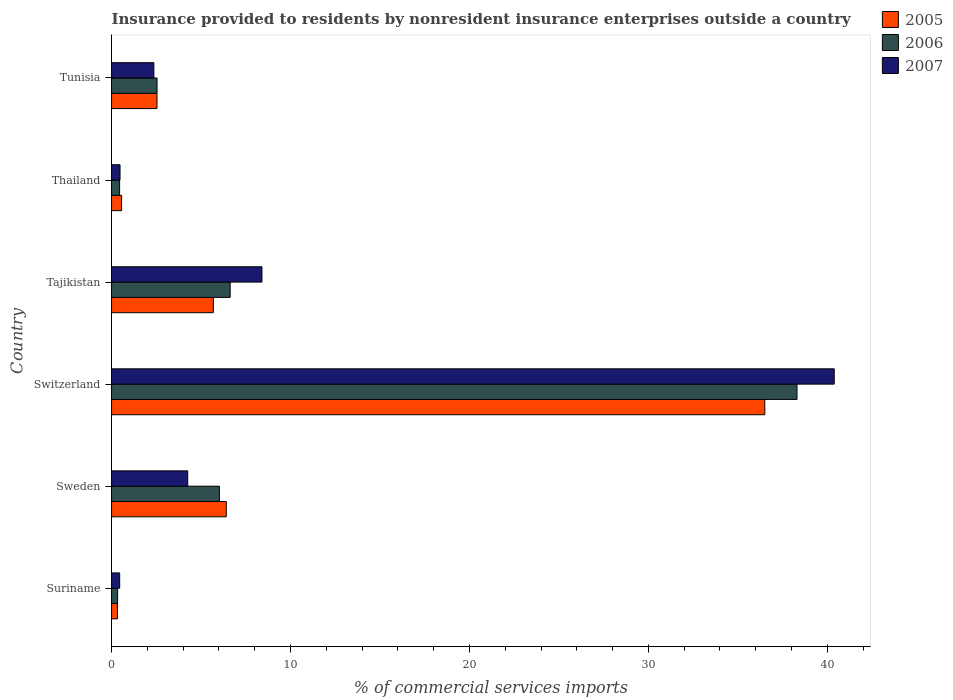How many different coloured bars are there?
Give a very brief answer. 3. How many groups of bars are there?
Keep it short and to the point. 6. Are the number of bars per tick equal to the number of legend labels?
Your answer should be compact. Yes. Are the number of bars on each tick of the Y-axis equal?
Provide a short and direct response. Yes. How many bars are there on the 1st tick from the top?
Ensure brevity in your answer.  3. How many bars are there on the 5th tick from the bottom?
Ensure brevity in your answer.  3. What is the label of the 1st group of bars from the top?
Your answer should be compact. Tunisia. In how many cases, is the number of bars for a given country not equal to the number of legend labels?
Your answer should be compact. 0. What is the Insurance provided to residents in 2005 in Tajikistan?
Keep it short and to the point. 5.69. Across all countries, what is the maximum Insurance provided to residents in 2006?
Offer a terse response. 38.3. Across all countries, what is the minimum Insurance provided to residents in 2005?
Keep it short and to the point. 0.33. In which country was the Insurance provided to residents in 2005 maximum?
Give a very brief answer. Switzerland. In which country was the Insurance provided to residents in 2006 minimum?
Give a very brief answer. Suriname. What is the total Insurance provided to residents in 2005 in the graph?
Ensure brevity in your answer.  52.03. What is the difference between the Insurance provided to residents in 2007 in Tajikistan and that in Tunisia?
Ensure brevity in your answer.  6.04. What is the difference between the Insurance provided to residents in 2005 in Tunisia and the Insurance provided to residents in 2007 in Switzerland?
Keep it short and to the point. -37.85. What is the average Insurance provided to residents in 2007 per country?
Ensure brevity in your answer.  9.39. What is the difference between the Insurance provided to residents in 2007 and Insurance provided to residents in 2005 in Tunisia?
Make the answer very short. -0.17. In how many countries, is the Insurance provided to residents in 2005 greater than 6 %?
Your answer should be compact. 2. What is the ratio of the Insurance provided to residents in 2006 in Sweden to that in Tunisia?
Keep it short and to the point. 2.37. Is the Insurance provided to residents in 2006 in Suriname less than that in Switzerland?
Your response must be concise. Yes. What is the difference between the highest and the second highest Insurance provided to residents in 2006?
Your answer should be very brief. 31.68. What is the difference between the highest and the lowest Insurance provided to residents in 2006?
Give a very brief answer. 37.97. In how many countries, is the Insurance provided to residents in 2007 greater than the average Insurance provided to residents in 2007 taken over all countries?
Your answer should be compact. 1. Is the sum of the Insurance provided to residents in 2007 in Suriname and Tunisia greater than the maximum Insurance provided to residents in 2006 across all countries?
Your response must be concise. No. Is it the case that in every country, the sum of the Insurance provided to residents in 2005 and Insurance provided to residents in 2007 is greater than the Insurance provided to residents in 2006?
Your answer should be compact. Yes. How many bars are there?
Your answer should be compact. 18. How many countries are there in the graph?
Offer a very short reply. 6. What is the difference between two consecutive major ticks on the X-axis?
Offer a very short reply. 10. Are the values on the major ticks of X-axis written in scientific E-notation?
Your answer should be very brief. No. What is the title of the graph?
Ensure brevity in your answer.  Insurance provided to residents by nonresident insurance enterprises outside a country. What is the label or title of the X-axis?
Your answer should be very brief. % of commercial services imports. What is the label or title of the Y-axis?
Give a very brief answer. Country. What is the % of commercial services imports of 2005 in Suriname?
Your answer should be compact. 0.33. What is the % of commercial services imports of 2006 in Suriname?
Provide a short and direct response. 0.34. What is the % of commercial services imports in 2007 in Suriname?
Provide a short and direct response. 0.45. What is the % of commercial services imports of 2005 in Sweden?
Your response must be concise. 6.41. What is the % of commercial services imports in 2006 in Sweden?
Your answer should be very brief. 6.03. What is the % of commercial services imports in 2007 in Sweden?
Offer a very short reply. 4.26. What is the % of commercial services imports in 2005 in Switzerland?
Your answer should be compact. 36.5. What is the % of commercial services imports of 2006 in Switzerland?
Make the answer very short. 38.3. What is the % of commercial services imports in 2007 in Switzerland?
Your response must be concise. 40.39. What is the % of commercial services imports of 2005 in Tajikistan?
Offer a terse response. 5.69. What is the % of commercial services imports in 2006 in Tajikistan?
Provide a succinct answer. 6.63. What is the % of commercial services imports of 2007 in Tajikistan?
Your answer should be very brief. 8.4. What is the % of commercial services imports in 2005 in Thailand?
Give a very brief answer. 0.56. What is the % of commercial services imports of 2006 in Thailand?
Keep it short and to the point. 0.45. What is the % of commercial services imports of 2007 in Thailand?
Ensure brevity in your answer.  0.47. What is the % of commercial services imports of 2005 in Tunisia?
Your answer should be compact. 2.54. What is the % of commercial services imports of 2006 in Tunisia?
Make the answer very short. 2.54. What is the % of commercial services imports in 2007 in Tunisia?
Give a very brief answer. 2.36. Across all countries, what is the maximum % of commercial services imports of 2005?
Your answer should be very brief. 36.5. Across all countries, what is the maximum % of commercial services imports in 2006?
Your answer should be compact. 38.3. Across all countries, what is the maximum % of commercial services imports in 2007?
Keep it short and to the point. 40.39. Across all countries, what is the minimum % of commercial services imports of 2005?
Your answer should be very brief. 0.33. Across all countries, what is the minimum % of commercial services imports of 2006?
Make the answer very short. 0.34. Across all countries, what is the minimum % of commercial services imports in 2007?
Offer a terse response. 0.45. What is the total % of commercial services imports of 2005 in the graph?
Offer a very short reply. 52.03. What is the total % of commercial services imports of 2006 in the graph?
Make the answer very short. 54.29. What is the total % of commercial services imports of 2007 in the graph?
Offer a terse response. 56.34. What is the difference between the % of commercial services imports in 2005 in Suriname and that in Sweden?
Give a very brief answer. -6.08. What is the difference between the % of commercial services imports of 2006 in Suriname and that in Sweden?
Ensure brevity in your answer.  -5.69. What is the difference between the % of commercial services imports in 2007 in Suriname and that in Sweden?
Provide a short and direct response. -3.8. What is the difference between the % of commercial services imports of 2005 in Suriname and that in Switzerland?
Your response must be concise. -36.18. What is the difference between the % of commercial services imports of 2006 in Suriname and that in Switzerland?
Your answer should be compact. -37.97. What is the difference between the % of commercial services imports in 2007 in Suriname and that in Switzerland?
Ensure brevity in your answer.  -39.93. What is the difference between the % of commercial services imports in 2005 in Suriname and that in Tajikistan?
Your answer should be compact. -5.36. What is the difference between the % of commercial services imports in 2006 in Suriname and that in Tajikistan?
Provide a short and direct response. -6.29. What is the difference between the % of commercial services imports in 2007 in Suriname and that in Tajikistan?
Keep it short and to the point. -7.95. What is the difference between the % of commercial services imports of 2005 in Suriname and that in Thailand?
Your answer should be very brief. -0.23. What is the difference between the % of commercial services imports in 2006 in Suriname and that in Thailand?
Offer a terse response. -0.11. What is the difference between the % of commercial services imports in 2007 in Suriname and that in Thailand?
Give a very brief answer. -0.02. What is the difference between the % of commercial services imports in 2005 in Suriname and that in Tunisia?
Provide a succinct answer. -2.21. What is the difference between the % of commercial services imports of 2006 in Suriname and that in Tunisia?
Offer a terse response. -2.2. What is the difference between the % of commercial services imports of 2007 in Suriname and that in Tunisia?
Provide a succinct answer. -1.91. What is the difference between the % of commercial services imports of 2005 in Sweden and that in Switzerland?
Your response must be concise. -30.09. What is the difference between the % of commercial services imports of 2006 in Sweden and that in Switzerland?
Ensure brevity in your answer.  -32.28. What is the difference between the % of commercial services imports of 2007 in Sweden and that in Switzerland?
Offer a terse response. -36.13. What is the difference between the % of commercial services imports in 2005 in Sweden and that in Tajikistan?
Ensure brevity in your answer.  0.73. What is the difference between the % of commercial services imports of 2006 in Sweden and that in Tajikistan?
Your answer should be compact. -0.6. What is the difference between the % of commercial services imports of 2007 in Sweden and that in Tajikistan?
Keep it short and to the point. -4.15. What is the difference between the % of commercial services imports of 2005 in Sweden and that in Thailand?
Provide a short and direct response. 5.85. What is the difference between the % of commercial services imports in 2006 in Sweden and that in Thailand?
Ensure brevity in your answer.  5.58. What is the difference between the % of commercial services imports in 2007 in Sweden and that in Thailand?
Your answer should be very brief. 3.78. What is the difference between the % of commercial services imports in 2005 in Sweden and that in Tunisia?
Your answer should be compact. 3.87. What is the difference between the % of commercial services imports of 2006 in Sweden and that in Tunisia?
Your answer should be compact. 3.49. What is the difference between the % of commercial services imports of 2007 in Sweden and that in Tunisia?
Your response must be concise. 1.89. What is the difference between the % of commercial services imports of 2005 in Switzerland and that in Tajikistan?
Give a very brief answer. 30.82. What is the difference between the % of commercial services imports in 2006 in Switzerland and that in Tajikistan?
Offer a terse response. 31.68. What is the difference between the % of commercial services imports of 2007 in Switzerland and that in Tajikistan?
Give a very brief answer. 31.98. What is the difference between the % of commercial services imports of 2005 in Switzerland and that in Thailand?
Give a very brief answer. 35.94. What is the difference between the % of commercial services imports of 2006 in Switzerland and that in Thailand?
Offer a terse response. 37.85. What is the difference between the % of commercial services imports in 2007 in Switzerland and that in Thailand?
Make the answer very short. 39.91. What is the difference between the % of commercial services imports of 2005 in Switzerland and that in Tunisia?
Give a very brief answer. 33.96. What is the difference between the % of commercial services imports in 2006 in Switzerland and that in Tunisia?
Provide a short and direct response. 35.76. What is the difference between the % of commercial services imports in 2007 in Switzerland and that in Tunisia?
Keep it short and to the point. 38.02. What is the difference between the % of commercial services imports of 2005 in Tajikistan and that in Thailand?
Keep it short and to the point. 5.13. What is the difference between the % of commercial services imports of 2006 in Tajikistan and that in Thailand?
Provide a succinct answer. 6.18. What is the difference between the % of commercial services imports in 2007 in Tajikistan and that in Thailand?
Offer a very short reply. 7.93. What is the difference between the % of commercial services imports of 2005 in Tajikistan and that in Tunisia?
Give a very brief answer. 3.15. What is the difference between the % of commercial services imports in 2006 in Tajikistan and that in Tunisia?
Make the answer very short. 4.09. What is the difference between the % of commercial services imports in 2007 in Tajikistan and that in Tunisia?
Provide a succinct answer. 6.04. What is the difference between the % of commercial services imports in 2005 in Thailand and that in Tunisia?
Offer a terse response. -1.98. What is the difference between the % of commercial services imports of 2006 in Thailand and that in Tunisia?
Your answer should be compact. -2.09. What is the difference between the % of commercial services imports in 2007 in Thailand and that in Tunisia?
Offer a very short reply. -1.89. What is the difference between the % of commercial services imports in 2005 in Suriname and the % of commercial services imports in 2006 in Sweden?
Offer a very short reply. -5.7. What is the difference between the % of commercial services imports of 2005 in Suriname and the % of commercial services imports of 2007 in Sweden?
Offer a very short reply. -3.93. What is the difference between the % of commercial services imports of 2006 in Suriname and the % of commercial services imports of 2007 in Sweden?
Make the answer very short. -3.92. What is the difference between the % of commercial services imports of 2005 in Suriname and the % of commercial services imports of 2006 in Switzerland?
Provide a short and direct response. -37.98. What is the difference between the % of commercial services imports in 2005 in Suriname and the % of commercial services imports in 2007 in Switzerland?
Offer a very short reply. -40.06. What is the difference between the % of commercial services imports in 2006 in Suriname and the % of commercial services imports in 2007 in Switzerland?
Make the answer very short. -40.05. What is the difference between the % of commercial services imports of 2005 in Suriname and the % of commercial services imports of 2006 in Tajikistan?
Give a very brief answer. -6.3. What is the difference between the % of commercial services imports in 2005 in Suriname and the % of commercial services imports in 2007 in Tajikistan?
Offer a terse response. -8.08. What is the difference between the % of commercial services imports in 2006 in Suriname and the % of commercial services imports in 2007 in Tajikistan?
Offer a terse response. -8.07. What is the difference between the % of commercial services imports of 2005 in Suriname and the % of commercial services imports of 2006 in Thailand?
Offer a very short reply. -0.12. What is the difference between the % of commercial services imports in 2005 in Suriname and the % of commercial services imports in 2007 in Thailand?
Your answer should be very brief. -0.14. What is the difference between the % of commercial services imports of 2006 in Suriname and the % of commercial services imports of 2007 in Thailand?
Provide a succinct answer. -0.14. What is the difference between the % of commercial services imports in 2005 in Suriname and the % of commercial services imports in 2006 in Tunisia?
Your answer should be very brief. -2.21. What is the difference between the % of commercial services imports in 2005 in Suriname and the % of commercial services imports in 2007 in Tunisia?
Your answer should be compact. -2.04. What is the difference between the % of commercial services imports in 2006 in Suriname and the % of commercial services imports in 2007 in Tunisia?
Give a very brief answer. -2.03. What is the difference between the % of commercial services imports in 2005 in Sweden and the % of commercial services imports in 2006 in Switzerland?
Ensure brevity in your answer.  -31.89. What is the difference between the % of commercial services imports in 2005 in Sweden and the % of commercial services imports in 2007 in Switzerland?
Provide a short and direct response. -33.97. What is the difference between the % of commercial services imports in 2006 in Sweden and the % of commercial services imports in 2007 in Switzerland?
Offer a terse response. -34.36. What is the difference between the % of commercial services imports in 2005 in Sweden and the % of commercial services imports in 2006 in Tajikistan?
Your response must be concise. -0.22. What is the difference between the % of commercial services imports of 2005 in Sweden and the % of commercial services imports of 2007 in Tajikistan?
Ensure brevity in your answer.  -1.99. What is the difference between the % of commercial services imports in 2006 in Sweden and the % of commercial services imports in 2007 in Tajikistan?
Provide a succinct answer. -2.38. What is the difference between the % of commercial services imports of 2005 in Sweden and the % of commercial services imports of 2006 in Thailand?
Make the answer very short. 5.96. What is the difference between the % of commercial services imports of 2005 in Sweden and the % of commercial services imports of 2007 in Thailand?
Make the answer very short. 5.94. What is the difference between the % of commercial services imports of 2006 in Sweden and the % of commercial services imports of 2007 in Thailand?
Ensure brevity in your answer.  5.55. What is the difference between the % of commercial services imports in 2005 in Sweden and the % of commercial services imports in 2006 in Tunisia?
Offer a terse response. 3.87. What is the difference between the % of commercial services imports of 2005 in Sweden and the % of commercial services imports of 2007 in Tunisia?
Provide a succinct answer. 4.05. What is the difference between the % of commercial services imports in 2006 in Sweden and the % of commercial services imports in 2007 in Tunisia?
Make the answer very short. 3.66. What is the difference between the % of commercial services imports in 2005 in Switzerland and the % of commercial services imports in 2006 in Tajikistan?
Offer a very short reply. 29.88. What is the difference between the % of commercial services imports of 2005 in Switzerland and the % of commercial services imports of 2007 in Tajikistan?
Give a very brief answer. 28.1. What is the difference between the % of commercial services imports of 2006 in Switzerland and the % of commercial services imports of 2007 in Tajikistan?
Provide a short and direct response. 29.9. What is the difference between the % of commercial services imports in 2005 in Switzerland and the % of commercial services imports in 2006 in Thailand?
Your answer should be compact. 36.05. What is the difference between the % of commercial services imports in 2005 in Switzerland and the % of commercial services imports in 2007 in Thailand?
Ensure brevity in your answer.  36.03. What is the difference between the % of commercial services imports of 2006 in Switzerland and the % of commercial services imports of 2007 in Thailand?
Your answer should be compact. 37.83. What is the difference between the % of commercial services imports of 2005 in Switzerland and the % of commercial services imports of 2006 in Tunisia?
Provide a succinct answer. 33.96. What is the difference between the % of commercial services imports in 2005 in Switzerland and the % of commercial services imports in 2007 in Tunisia?
Provide a succinct answer. 34.14. What is the difference between the % of commercial services imports in 2006 in Switzerland and the % of commercial services imports in 2007 in Tunisia?
Your response must be concise. 35.94. What is the difference between the % of commercial services imports in 2005 in Tajikistan and the % of commercial services imports in 2006 in Thailand?
Your response must be concise. 5.24. What is the difference between the % of commercial services imports in 2005 in Tajikistan and the % of commercial services imports in 2007 in Thailand?
Your answer should be very brief. 5.21. What is the difference between the % of commercial services imports of 2006 in Tajikistan and the % of commercial services imports of 2007 in Thailand?
Provide a succinct answer. 6.16. What is the difference between the % of commercial services imports of 2005 in Tajikistan and the % of commercial services imports of 2006 in Tunisia?
Your answer should be compact. 3.14. What is the difference between the % of commercial services imports in 2005 in Tajikistan and the % of commercial services imports in 2007 in Tunisia?
Provide a short and direct response. 3.32. What is the difference between the % of commercial services imports in 2006 in Tajikistan and the % of commercial services imports in 2007 in Tunisia?
Your answer should be very brief. 4.26. What is the difference between the % of commercial services imports of 2005 in Thailand and the % of commercial services imports of 2006 in Tunisia?
Give a very brief answer. -1.98. What is the difference between the % of commercial services imports in 2005 in Thailand and the % of commercial services imports in 2007 in Tunisia?
Provide a succinct answer. -1.8. What is the difference between the % of commercial services imports in 2006 in Thailand and the % of commercial services imports in 2007 in Tunisia?
Make the answer very short. -1.92. What is the average % of commercial services imports in 2005 per country?
Make the answer very short. 8.67. What is the average % of commercial services imports in 2006 per country?
Provide a succinct answer. 9.05. What is the average % of commercial services imports in 2007 per country?
Your answer should be very brief. 9.39. What is the difference between the % of commercial services imports in 2005 and % of commercial services imports in 2006 in Suriname?
Provide a succinct answer. -0.01. What is the difference between the % of commercial services imports of 2005 and % of commercial services imports of 2007 in Suriname?
Ensure brevity in your answer.  -0.13. What is the difference between the % of commercial services imports of 2006 and % of commercial services imports of 2007 in Suriname?
Provide a succinct answer. -0.12. What is the difference between the % of commercial services imports of 2005 and % of commercial services imports of 2006 in Sweden?
Provide a short and direct response. 0.38. What is the difference between the % of commercial services imports in 2005 and % of commercial services imports in 2007 in Sweden?
Offer a terse response. 2.16. What is the difference between the % of commercial services imports in 2006 and % of commercial services imports in 2007 in Sweden?
Make the answer very short. 1.77. What is the difference between the % of commercial services imports in 2005 and % of commercial services imports in 2006 in Switzerland?
Your answer should be compact. -1.8. What is the difference between the % of commercial services imports in 2005 and % of commercial services imports in 2007 in Switzerland?
Your answer should be compact. -3.88. What is the difference between the % of commercial services imports in 2006 and % of commercial services imports in 2007 in Switzerland?
Ensure brevity in your answer.  -2.08. What is the difference between the % of commercial services imports of 2005 and % of commercial services imports of 2006 in Tajikistan?
Give a very brief answer. -0.94. What is the difference between the % of commercial services imports in 2005 and % of commercial services imports in 2007 in Tajikistan?
Make the answer very short. -2.72. What is the difference between the % of commercial services imports of 2006 and % of commercial services imports of 2007 in Tajikistan?
Offer a terse response. -1.78. What is the difference between the % of commercial services imports of 2005 and % of commercial services imports of 2006 in Thailand?
Your response must be concise. 0.11. What is the difference between the % of commercial services imports of 2005 and % of commercial services imports of 2007 in Thailand?
Keep it short and to the point. 0.09. What is the difference between the % of commercial services imports in 2006 and % of commercial services imports in 2007 in Thailand?
Give a very brief answer. -0.02. What is the difference between the % of commercial services imports of 2005 and % of commercial services imports of 2006 in Tunisia?
Provide a succinct answer. -0. What is the difference between the % of commercial services imports in 2005 and % of commercial services imports in 2007 in Tunisia?
Keep it short and to the point. 0.17. What is the difference between the % of commercial services imports of 2006 and % of commercial services imports of 2007 in Tunisia?
Offer a very short reply. 0.18. What is the ratio of the % of commercial services imports of 2005 in Suriname to that in Sweden?
Offer a terse response. 0.05. What is the ratio of the % of commercial services imports in 2006 in Suriname to that in Sweden?
Offer a terse response. 0.06. What is the ratio of the % of commercial services imports of 2007 in Suriname to that in Sweden?
Offer a terse response. 0.11. What is the ratio of the % of commercial services imports of 2005 in Suriname to that in Switzerland?
Ensure brevity in your answer.  0.01. What is the ratio of the % of commercial services imports of 2006 in Suriname to that in Switzerland?
Keep it short and to the point. 0.01. What is the ratio of the % of commercial services imports in 2007 in Suriname to that in Switzerland?
Your response must be concise. 0.01. What is the ratio of the % of commercial services imports of 2005 in Suriname to that in Tajikistan?
Offer a very short reply. 0.06. What is the ratio of the % of commercial services imports of 2006 in Suriname to that in Tajikistan?
Offer a terse response. 0.05. What is the ratio of the % of commercial services imports of 2007 in Suriname to that in Tajikistan?
Give a very brief answer. 0.05. What is the ratio of the % of commercial services imports of 2005 in Suriname to that in Thailand?
Your response must be concise. 0.59. What is the ratio of the % of commercial services imports of 2006 in Suriname to that in Thailand?
Your answer should be very brief. 0.75. What is the ratio of the % of commercial services imports of 2007 in Suriname to that in Thailand?
Your response must be concise. 0.96. What is the ratio of the % of commercial services imports of 2005 in Suriname to that in Tunisia?
Offer a terse response. 0.13. What is the ratio of the % of commercial services imports of 2006 in Suriname to that in Tunisia?
Offer a terse response. 0.13. What is the ratio of the % of commercial services imports of 2007 in Suriname to that in Tunisia?
Your response must be concise. 0.19. What is the ratio of the % of commercial services imports in 2005 in Sweden to that in Switzerland?
Offer a terse response. 0.18. What is the ratio of the % of commercial services imports of 2006 in Sweden to that in Switzerland?
Offer a terse response. 0.16. What is the ratio of the % of commercial services imports in 2007 in Sweden to that in Switzerland?
Keep it short and to the point. 0.11. What is the ratio of the % of commercial services imports in 2005 in Sweden to that in Tajikistan?
Provide a succinct answer. 1.13. What is the ratio of the % of commercial services imports of 2006 in Sweden to that in Tajikistan?
Provide a succinct answer. 0.91. What is the ratio of the % of commercial services imports in 2007 in Sweden to that in Tajikistan?
Provide a short and direct response. 0.51. What is the ratio of the % of commercial services imports of 2005 in Sweden to that in Thailand?
Provide a succinct answer. 11.43. What is the ratio of the % of commercial services imports in 2006 in Sweden to that in Thailand?
Your response must be concise. 13.41. What is the ratio of the % of commercial services imports in 2007 in Sweden to that in Thailand?
Ensure brevity in your answer.  9. What is the ratio of the % of commercial services imports of 2005 in Sweden to that in Tunisia?
Ensure brevity in your answer.  2.53. What is the ratio of the % of commercial services imports in 2006 in Sweden to that in Tunisia?
Provide a succinct answer. 2.37. What is the ratio of the % of commercial services imports in 2005 in Switzerland to that in Tajikistan?
Provide a succinct answer. 6.42. What is the ratio of the % of commercial services imports of 2006 in Switzerland to that in Tajikistan?
Your response must be concise. 5.78. What is the ratio of the % of commercial services imports of 2007 in Switzerland to that in Tajikistan?
Make the answer very short. 4.81. What is the ratio of the % of commercial services imports of 2005 in Switzerland to that in Thailand?
Your answer should be very brief. 65.07. What is the ratio of the % of commercial services imports of 2006 in Switzerland to that in Thailand?
Your answer should be compact. 85.22. What is the ratio of the % of commercial services imports of 2007 in Switzerland to that in Thailand?
Offer a terse response. 85.36. What is the ratio of the % of commercial services imports of 2005 in Switzerland to that in Tunisia?
Your answer should be very brief. 14.38. What is the ratio of the % of commercial services imports in 2006 in Switzerland to that in Tunisia?
Your answer should be compact. 15.07. What is the ratio of the % of commercial services imports in 2007 in Switzerland to that in Tunisia?
Offer a very short reply. 17.08. What is the ratio of the % of commercial services imports of 2005 in Tajikistan to that in Thailand?
Provide a succinct answer. 10.14. What is the ratio of the % of commercial services imports in 2006 in Tajikistan to that in Thailand?
Keep it short and to the point. 14.75. What is the ratio of the % of commercial services imports of 2007 in Tajikistan to that in Thailand?
Make the answer very short. 17.76. What is the ratio of the % of commercial services imports in 2005 in Tajikistan to that in Tunisia?
Provide a short and direct response. 2.24. What is the ratio of the % of commercial services imports in 2006 in Tajikistan to that in Tunisia?
Offer a very short reply. 2.61. What is the ratio of the % of commercial services imports of 2007 in Tajikistan to that in Tunisia?
Your answer should be compact. 3.55. What is the ratio of the % of commercial services imports in 2005 in Thailand to that in Tunisia?
Offer a very short reply. 0.22. What is the ratio of the % of commercial services imports of 2006 in Thailand to that in Tunisia?
Your response must be concise. 0.18. What is the ratio of the % of commercial services imports in 2007 in Thailand to that in Tunisia?
Ensure brevity in your answer.  0.2. What is the difference between the highest and the second highest % of commercial services imports of 2005?
Provide a short and direct response. 30.09. What is the difference between the highest and the second highest % of commercial services imports of 2006?
Offer a very short reply. 31.68. What is the difference between the highest and the second highest % of commercial services imports in 2007?
Provide a succinct answer. 31.98. What is the difference between the highest and the lowest % of commercial services imports in 2005?
Provide a succinct answer. 36.18. What is the difference between the highest and the lowest % of commercial services imports of 2006?
Provide a short and direct response. 37.97. What is the difference between the highest and the lowest % of commercial services imports in 2007?
Keep it short and to the point. 39.93. 